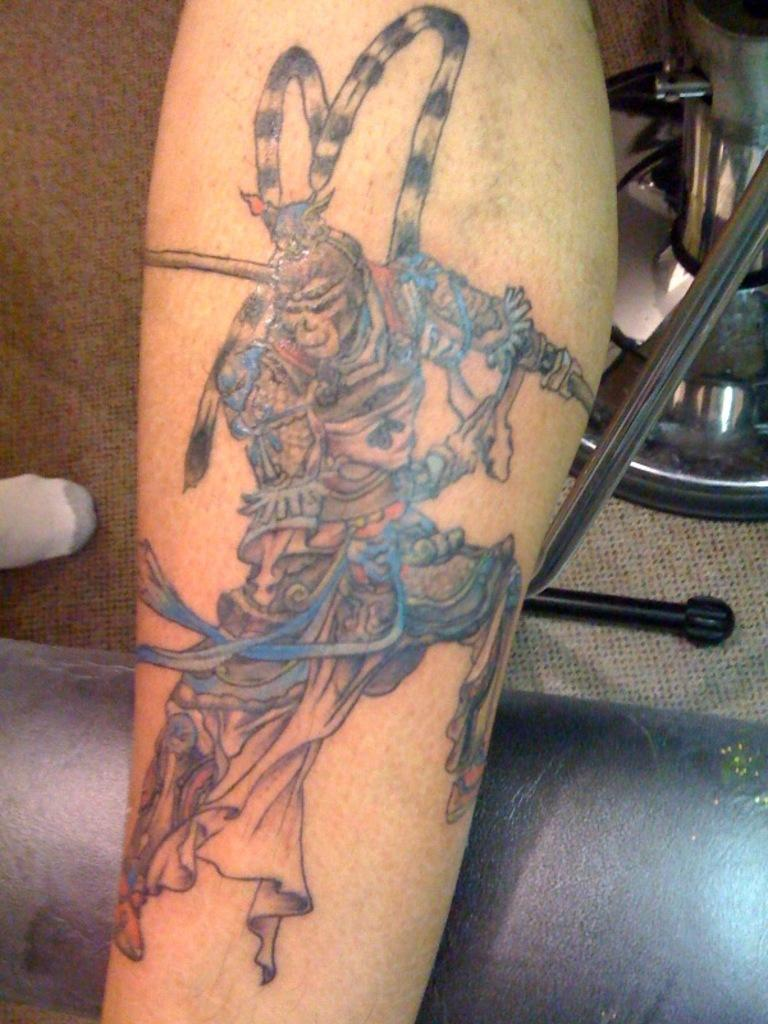What is visible on the person's leg in the image? There is a tattoo on a person's leg in the image. What can be seen in the background of the image? There are objects in the background of the image. How many frogs are feeling ashamed in the image? There are no frogs present in the image, and therefore no feelings of shame can be attributed to them. 